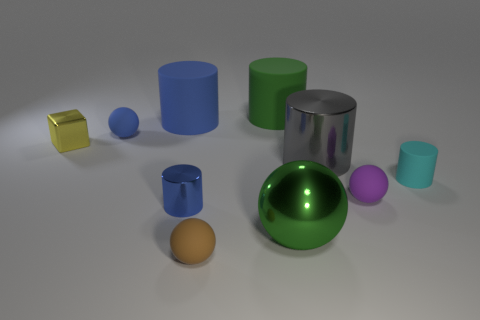Subtract all large gray cylinders. How many cylinders are left? 4 Subtract all cyan cylinders. How many cylinders are left? 4 Subtract all purple cylinders. Subtract all red blocks. How many cylinders are left? 5 Subtract all balls. How many objects are left? 6 Subtract all small purple things. Subtract all metal objects. How many objects are left? 5 Add 6 big cylinders. How many big cylinders are left? 9 Add 7 metallic blocks. How many metallic blocks exist? 8 Subtract 0 brown cylinders. How many objects are left? 10 